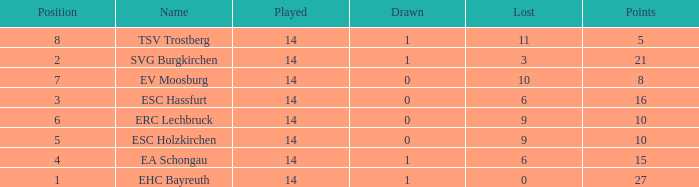What's the points that has a lost more 6, played less than 14 and a position more than 1? None. 